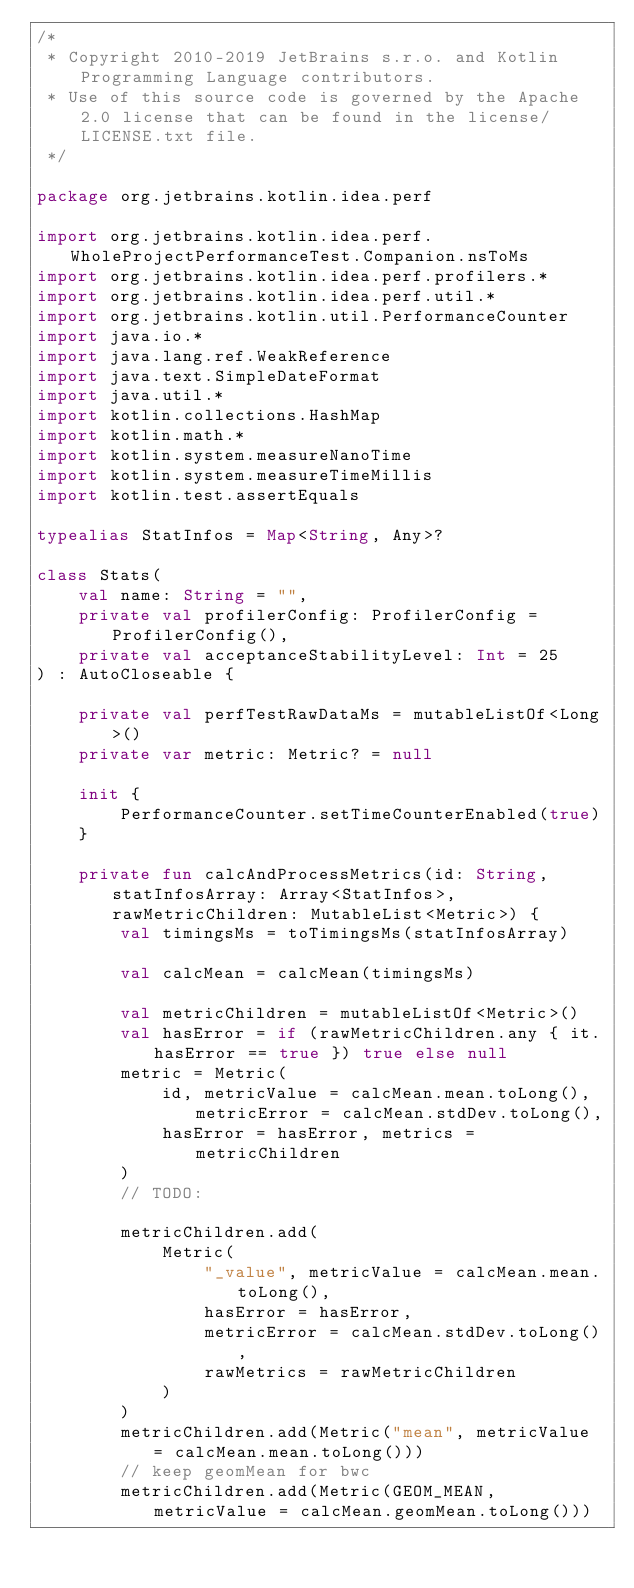<code> <loc_0><loc_0><loc_500><loc_500><_Kotlin_>/*
 * Copyright 2010-2019 JetBrains s.r.o. and Kotlin Programming Language contributors.
 * Use of this source code is governed by the Apache 2.0 license that can be found in the license/LICENSE.txt file.
 */

package org.jetbrains.kotlin.idea.perf

import org.jetbrains.kotlin.idea.perf.WholeProjectPerformanceTest.Companion.nsToMs
import org.jetbrains.kotlin.idea.perf.profilers.*
import org.jetbrains.kotlin.idea.perf.util.*
import org.jetbrains.kotlin.util.PerformanceCounter
import java.io.*
import java.lang.ref.WeakReference
import java.text.SimpleDateFormat
import java.util.*
import kotlin.collections.HashMap
import kotlin.math.*
import kotlin.system.measureNanoTime
import kotlin.system.measureTimeMillis
import kotlin.test.assertEquals

typealias StatInfos = Map<String, Any>?

class Stats(
    val name: String = "",
    private val profilerConfig: ProfilerConfig = ProfilerConfig(),
    private val acceptanceStabilityLevel: Int = 25
) : AutoCloseable {

    private val perfTestRawDataMs = mutableListOf<Long>()
    private var metric: Metric? = null

    init {
        PerformanceCounter.setTimeCounterEnabled(true)
    }

    private fun calcAndProcessMetrics(id: String, statInfosArray: Array<StatInfos>, rawMetricChildren: MutableList<Metric>) {
        val timingsMs = toTimingsMs(statInfosArray)

        val calcMean = calcMean(timingsMs)

        val metricChildren = mutableListOf<Metric>()
        val hasError = if (rawMetricChildren.any { it.hasError == true }) true else null
        metric = Metric(
            id, metricValue = calcMean.mean.toLong(), metricError = calcMean.stdDev.toLong(),
            hasError = hasError, metrics = metricChildren
        )
        // TODO:

        metricChildren.add(
            Metric(
                "_value", metricValue = calcMean.mean.toLong(),
                hasError = hasError,
                metricError = calcMean.stdDev.toLong(),
                rawMetrics = rawMetricChildren
            )
        )
        metricChildren.add(Metric("mean", metricValue = calcMean.mean.toLong()))
        // keep geomMean for bwc
        metricChildren.add(Metric(GEOM_MEAN, metricValue = calcMean.geomMean.toLong()))</code> 